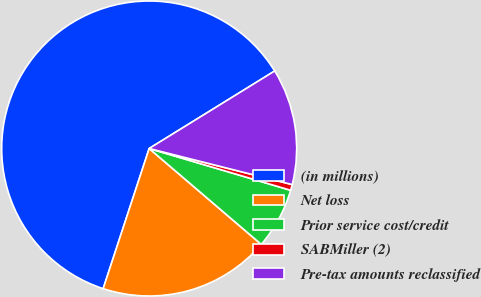Convert chart. <chart><loc_0><loc_0><loc_500><loc_500><pie_chart><fcel>(in millions)<fcel>Net loss<fcel>Prior service cost/credit<fcel>SABMiller (2)<fcel>Pre-tax amounts reclassified<nl><fcel>61.15%<fcel>18.79%<fcel>6.69%<fcel>0.64%<fcel>12.74%<nl></chart> 